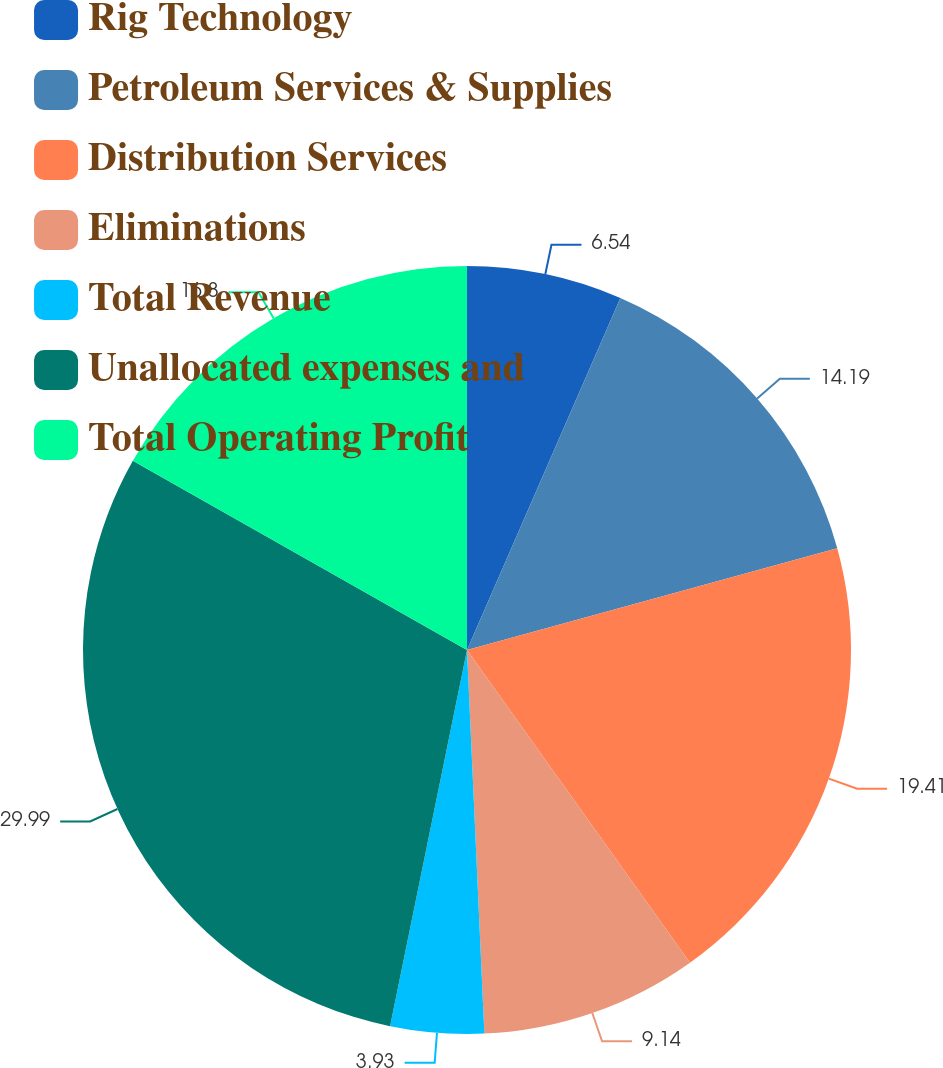<chart> <loc_0><loc_0><loc_500><loc_500><pie_chart><fcel>Rig Technology<fcel>Petroleum Services & Supplies<fcel>Distribution Services<fcel>Eliminations<fcel>Total Revenue<fcel>Unallocated expenses and<fcel>Total Operating Profit<nl><fcel>6.54%<fcel>14.19%<fcel>19.41%<fcel>9.14%<fcel>3.93%<fcel>29.99%<fcel>16.8%<nl></chart> 